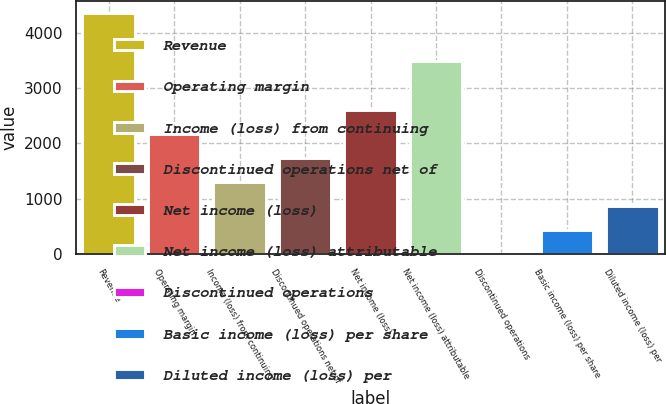Convert chart. <chart><loc_0><loc_0><loc_500><loc_500><bar_chart><fcel>Revenue<fcel>Operating margin<fcel>Income (loss) from continuing<fcel>Discontinued operations net of<fcel>Net income (loss)<fcel>Net income (loss) attributable<fcel>Discontinued operations<fcel>Basic income (loss) per share<fcel>Diluted income (loss) per<nl><fcel>4353<fcel>2176.52<fcel>1305.92<fcel>1741.22<fcel>2611.82<fcel>3482.42<fcel>0.02<fcel>435.32<fcel>870.62<nl></chart> 